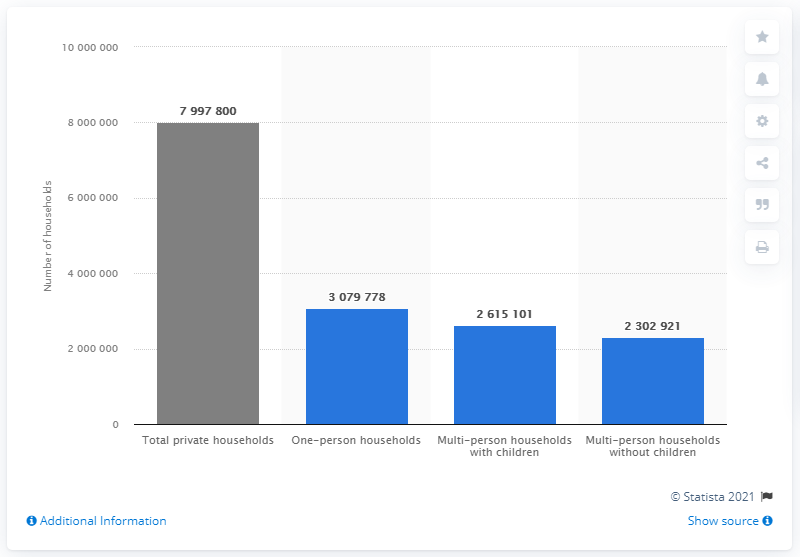Highlight a few significant elements in this photo. In the Netherlands, there are approximately 3079778 households composed of single men and women. In 2020, a total of 230,292,123 households were formed by couples without children. 